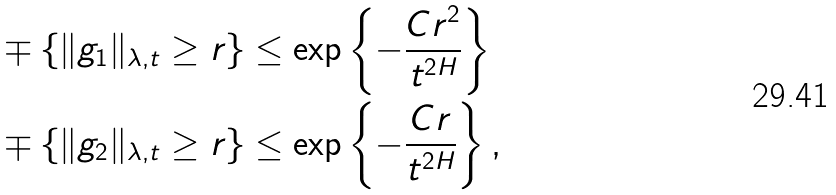Convert formula to latex. <formula><loc_0><loc_0><loc_500><loc_500>& \mp \{ \| g _ { 1 } \| _ { \lambda , t } \geq r \} \leq \exp \left \{ - \frac { C r ^ { 2 } } { t ^ { 2 H } } \right \} \\ & \mp \{ \| g _ { 2 } \| _ { \lambda , t } \geq r \} \leq \exp \left \{ - \frac { C r } { t ^ { 2 H } } \right \} ,</formula> 